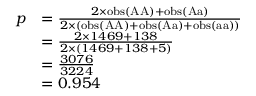<formula> <loc_0><loc_0><loc_500><loc_500>{ \begin{array} { r l } { p } & { = { \frac { 2 \times o b s ( { A A } ) + o b s ( { A a } ) } { 2 \times ( o b s ( { A A } ) + o b s ( { A a } ) + o b s ( { a a } ) ) } } } \\ & { = { \frac { 2 \times 1 4 6 9 + 1 3 8 } { 2 \times ( 1 4 6 9 + 1 3 8 + 5 ) } } } \\ & { = { \frac { 3 0 7 6 } { 3 2 2 4 } } } \\ & { = 0 . 9 5 4 } \end{array} }</formula> 